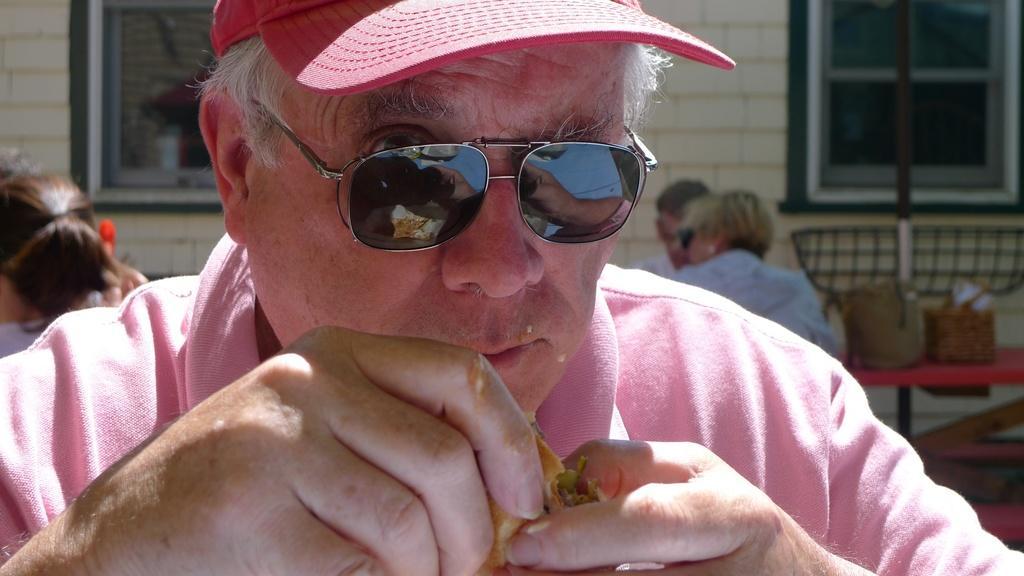Could you give a brief overview of what you see in this image? In this image there is a person with a hat and spectacles holding a food item ,and in the background there are group of people sitting, table, windows of a building. 